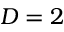<formula> <loc_0><loc_0><loc_500><loc_500>D = 2</formula> 